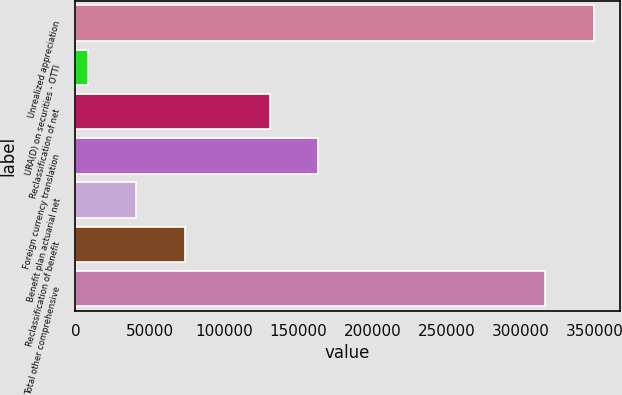<chart> <loc_0><loc_0><loc_500><loc_500><bar_chart><fcel>Unrealized appreciation<fcel>URA(D) on securities - OTTI<fcel>Reclassification of net<fcel>Foreign currency translation<fcel>Benefit plan actuarial net<fcel>Reclassification of benefit<fcel>Total other comprehensive<nl><fcel>349175<fcel>8411<fcel>131211<fcel>163736<fcel>40935.6<fcel>73460.2<fcel>316650<nl></chart> 